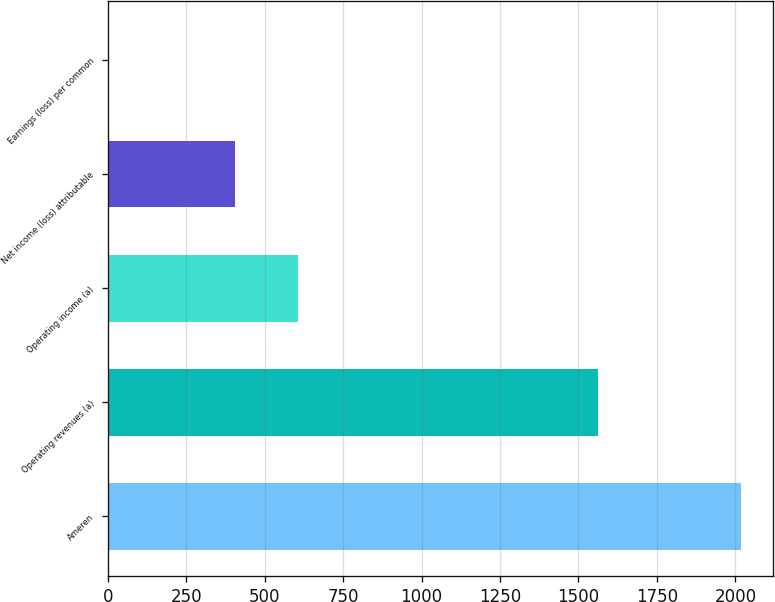<chart> <loc_0><loc_0><loc_500><loc_500><bar_chart><fcel>Ameren<fcel>Operating revenues (a)<fcel>Operating income (a)<fcel>Net income (loss) attributable<fcel>Earnings (loss) per common<nl><fcel>2018<fcel>1563<fcel>606.07<fcel>404.37<fcel>0.97<nl></chart> 